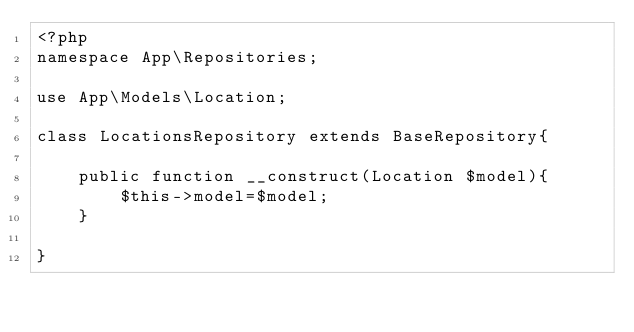Convert code to text. <code><loc_0><loc_0><loc_500><loc_500><_PHP_><?php
namespace App\Repositories;

use App\Models\Location;

class LocationsRepository extends BaseRepository{

    public function __construct(Location $model){
        $this->model=$model;
    } 

}</code> 